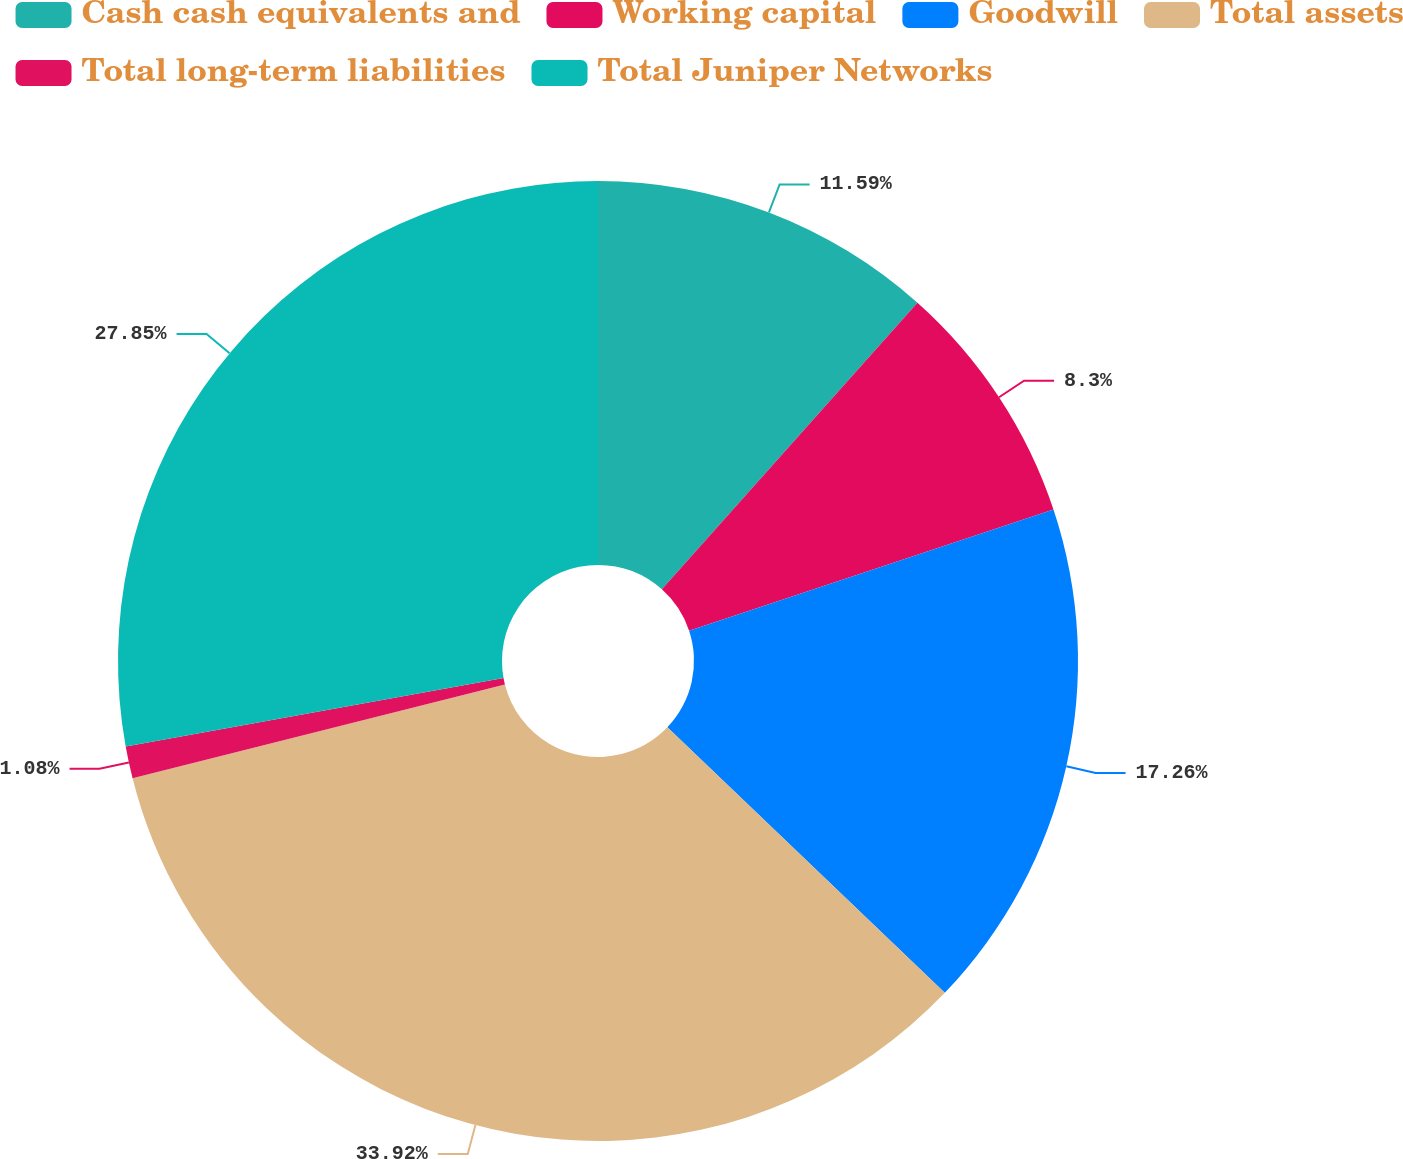<chart> <loc_0><loc_0><loc_500><loc_500><pie_chart><fcel>Cash cash equivalents and<fcel>Working capital<fcel>Goodwill<fcel>Total assets<fcel>Total long-term liabilities<fcel>Total Juniper Networks<nl><fcel>11.59%<fcel>8.3%<fcel>17.26%<fcel>33.92%<fcel>1.08%<fcel>27.85%<nl></chart> 